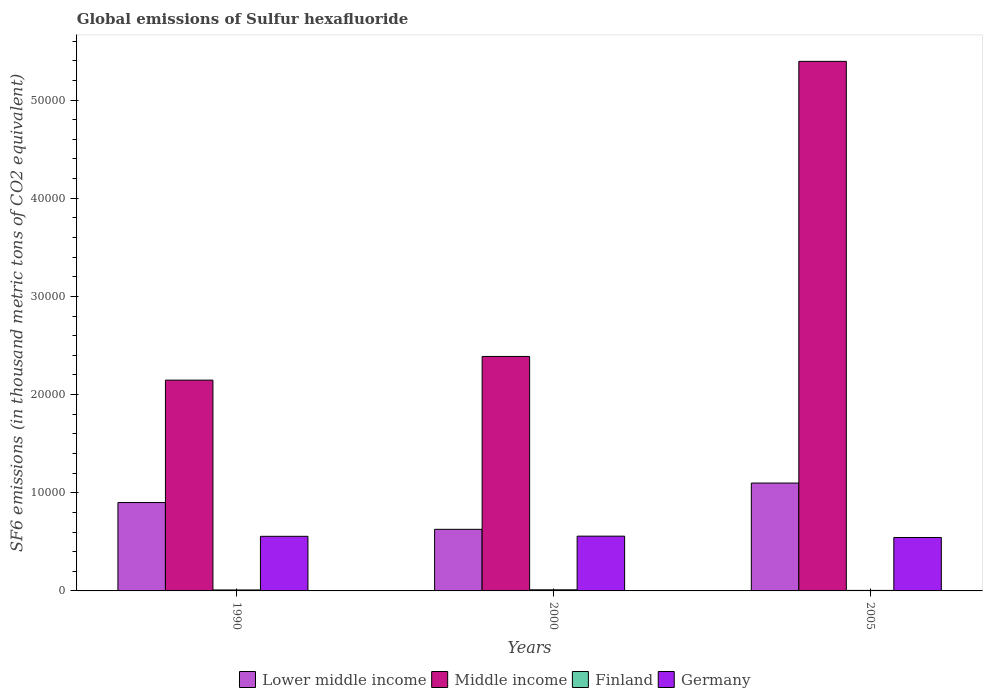How many groups of bars are there?
Your answer should be compact. 3. Are the number of bars per tick equal to the number of legend labels?
Your answer should be very brief. Yes. Are the number of bars on each tick of the X-axis equal?
Provide a succinct answer. Yes. How many bars are there on the 3rd tick from the left?
Give a very brief answer. 4. What is the label of the 3rd group of bars from the left?
Your answer should be compact. 2005. What is the global emissions of Sulfur hexafluoride in Middle income in 1990?
Offer a terse response. 2.15e+04. Across all years, what is the maximum global emissions of Sulfur hexafluoride in Finland?
Make the answer very short. 113.9. Across all years, what is the minimum global emissions of Sulfur hexafluoride in Germany?
Provide a succinct answer. 5443.2. In which year was the global emissions of Sulfur hexafluoride in Lower middle income maximum?
Your response must be concise. 2005. In which year was the global emissions of Sulfur hexafluoride in Germany minimum?
Make the answer very short. 2005. What is the total global emissions of Sulfur hexafluoride in Finland in the graph?
Keep it short and to the point. 263.2. What is the difference between the global emissions of Sulfur hexafluoride in Lower middle income in 1990 and that in 2000?
Keep it short and to the point. 2727.4. What is the difference between the global emissions of Sulfur hexafluoride in Germany in 2000 and the global emissions of Sulfur hexafluoride in Middle income in 1990?
Offer a terse response. -1.59e+04. What is the average global emissions of Sulfur hexafluoride in Germany per year?
Offer a very short reply. 5528.83. In the year 1990, what is the difference between the global emissions of Sulfur hexafluoride in Finland and global emissions of Sulfur hexafluoride in Lower middle income?
Provide a short and direct response. -8904.4. In how many years, is the global emissions of Sulfur hexafluoride in Germany greater than 2000 thousand metric tons?
Give a very brief answer. 3. What is the ratio of the global emissions of Sulfur hexafluoride in Germany in 2000 to that in 2005?
Your response must be concise. 1.03. Is the global emissions of Sulfur hexafluoride in Germany in 1990 less than that in 2005?
Provide a succinct answer. No. Is the difference between the global emissions of Sulfur hexafluoride in Finland in 2000 and 2005 greater than the difference between the global emissions of Sulfur hexafluoride in Lower middle income in 2000 and 2005?
Give a very brief answer. Yes. What is the difference between the highest and the second highest global emissions of Sulfur hexafluoride in Germany?
Give a very brief answer. 17.5. What is the difference between the highest and the lowest global emissions of Sulfur hexafluoride in Lower middle income?
Your response must be concise. 4713.67. What does the 3rd bar from the left in 2000 represents?
Your response must be concise. Finland. What does the 1st bar from the right in 1990 represents?
Offer a very short reply. Germany. Is it the case that in every year, the sum of the global emissions of Sulfur hexafluoride in Germany and global emissions of Sulfur hexafluoride in Middle income is greater than the global emissions of Sulfur hexafluoride in Finland?
Offer a terse response. Yes. Are all the bars in the graph horizontal?
Offer a terse response. No. How many years are there in the graph?
Keep it short and to the point. 3. What is the difference between two consecutive major ticks on the Y-axis?
Offer a very short reply. 10000. Does the graph contain grids?
Ensure brevity in your answer.  No. Where does the legend appear in the graph?
Keep it short and to the point. Bottom center. What is the title of the graph?
Provide a short and direct response. Global emissions of Sulfur hexafluoride. What is the label or title of the Y-axis?
Make the answer very short. SF6 emissions (in thousand metric tons of CO2 equivalent). What is the SF6 emissions (in thousand metric tons of CO2 equivalent) in Lower middle income in 1990?
Provide a succinct answer. 9002.8. What is the SF6 emissions (in thousand metric tons of CO2 equivalent) of Middle income in 1990?
Give a very brief answer. 2.15e+04. What is the SF6 emissions (in thousand metric tons of CO2 equivalent) in Finland in 1990?
Provide a succinct answer. 98.4. What is the SF6 emissions (in thousand metric tons of CO2 equivalent) in Germany in 1990?
Offer a very short reply. 5562.9. What is the SF6 emissions (in thousand metric tons of CO2 equivalent) in Lower middle income in 2000?
Provide a succinct answer. 6275.4. What is the SF6 emissions (in thousand metric tons of CO2 equivalent) in Middle income in 2000?
Ensure brevity in your answer.  2.39e+04. What is the SF6 emissions (in thousand metric tons of CO2 equivalent) in Finland in 2000?
Ensure brevity in your answer.  113.9. What is the SF6 emissions (in thousand metric tons of CO2 equivalent) of Germany in 2000?
Provide a short and direct response. 5580.4. What is the SF6 emissions (in thousand metric tons of CO2 equivalent) of Lower middle income in 2005?
Offer a terse response. 1.10e+04. What is the SF6 emissions (in thousand metric tons of CO2 equivalent) of Middle income in 2005?
Ensure brevity in your answer.  5.39e+04. What is the SF6 emissions (in thousand metric tons of CO2 equivalent) in Finland in 2005?
Provide a succinct answer. 50.9. What is the SF6 emissions (in thousand metric tons of CO2 equivalent) in Germany in 2005?
Give a very brief answer. 5443.2. Across all years, what is the maximum SF6 emissions (in thousand metric tons of CO2 equivalent) of Lower middle income?
Offer a very short reply. 1.10e+04. Across all years, what is the maximum SF6 emissions (in thousand metric tons of CO2 equivalent) of Middle income?
Offer a very short reply. 5.39e+04. Across all years, what is the maximum SF6 emissions (in thousand metric tons of CO2 equivalent) of Finland?
Ensure brevity in your answer.  113.9. Across all years, what is the maximum SF6 emissions (in thousand metric tons of CO2 equivalent) in Germany?
Make the answer very short. 5580.4. Across all years, what is the minimum SF6 emissions (in thousand metric tons of CO2 equivalent) of Lower middle income?
Your answer should be compact. 6275.4. Across all years, what is the minimum SF6 emissions (in thousand metric tons of CO2 equivalent) of Middle income?
Keep it short and to the point. 2.15e+04. Across all years, what is the minimum SF6 emissions (in thousand metric tons of CO2 equivalent) in Finland?
Offer a very short reply. 50.9. Across all years, what is the minimum SF6 emissions (in thousand metric tons of CO2 equivalent) in Germany?
Make the answer very short. 5443.2. What is the total SF6 emissions (in thousand metric tons of CO2 equivalent) in Lower middle income in the graph?
Offer a very short reply. 2.63e+04. What is the total SF6 emissions (in thousand metric tons of CO2 equivalent) in Middle income in the graph?
Offer a very short reply. 9.93e+04. What is the total SF6 emissions (in thousand metric tons of CO2 equivalent) in Finland in the graph?
Provide a short and direct response. 263.2. What is the total SF6 emissions (in thousand metric tons of CO2 equivalent) of Germany in the graph?
Provide a short and direct response. 1.66e+04. What is the difference between the SF6 emissions (in thousand metric tons of CO2 equivalent) in Lower middle income in 1990 and that in 2000?
Keep it short and to the point. 2727.4. What is the difference between the SF6 emissions (in thousand metric tons of CO2 equivalent) in Middle income in 1990 and that in 2000?
Give a very brief answer. -2413.4. What is the difference between the SF6 emissions (in thousand metric tons of CO2 equivalent) of Finland in 1990 and that in 2000?
Keep it short and to the point. -15.5. What is the difference between the SF6 emissions (in thousand metric tons of CO2 equivalent) in Germany in 1990 and that in 2000?
Keep it short and to the point. -17.5. What is the difference between the SF6 emissions (in thousand metric tons of CO2 equivalent) of Lower middle income in 1990 and that in 2005?
Provide a short and direct response. -1986.27. What is the difference between the SF6 emissions (in thousand metric tons of CO2 equivalent) in Middle income in 1990 and that in 2005?
Provide a short and direct response. -3.25e+04. What is the difference between the SF6 emissions (in thousand metric tons of CO2 equivalent) in Finland in 1990 and that in 2005?
Keep it short and to the point. 47.5. What is the difference between the SF6 emissions (in thousand metric tons of CO2 equivalent) in Germany in 1990 and that in 2005?
Keep it short and to the point. 119.7. What is the difference between the SF6 emissions (in thousand metric tons of CO2 equivalent) of Lower middle income in 2000 and that in 2005?
Make the answer very short. -4713.67. What is the difference between the SF6 emissions (in thousand metric tons of CO2 equivalent) in Middle income in 2000 and that in 2005?
Your answer should be compact. -3.01e+04. What is the difference between the SF6 emissions (in thousand metric tons of CO2 equivalent) of Finland in 2000 and that in 2005?
Your answer should be compact. 63. What is the difference between the SF6 emissions (in thousand metric tons of CO2 equivalent) of Germany in 2000 and that in 2005?
Keep it short and to the point. 137.2. What is the difference between the SF6 emissions (in thousand metric tons of CO2 equivalent) in Lower middle income in 1990 and the SF6 emissions (in thousand metric tons of CO2 equivalent) in Middle income in 2000?
Your answer should be compact. -1.49e+04. What is the difference between the SF6 emissions (in thousand metric tons of CO2 equivalent) of Lower middle income in 1990 and the SF6 emissions (in thousand metric tons of CO2 equivalent) of Finland in 2000?
Keep it short and to the point. 8888.9. What is the difference between the SF6 emissions (in thousand metric tons of CO2 equivalent) of Lower middle income in 1990 and the SF6 emissions (in thousand metric tons of CO2 equivalent) of Germany in 2000?
Your answer should be compact. 3422.4. What is the difference between the SF6 emissions (in thousand metric tons of CO2 equivalent) of Middle income in 1990 and the SF6 emissions (in thousand metric tons of CO2 equivalent) of Finland in 2000?
Make the answer very short. 2.14e+04. What is the difference between the SF6 emissions (in thousand metric tons of CO2 equivalent) in Middle income in 1990 and the SF6 emissions (in thousand metric tons of CO2 equivalent) in Germany in 2000?
Offer a very short reply. 1.59e+04. What is the difference between the SF6 emissions (in thousand metric tons of CO2 equivalent) of Finland in 1990 and the SF6 emissions (in thousand metric tons of CO2 equivalent) of Germany in 2000?
Make the answer very short. -5482. What is the difference between the SF6 emissions (in thousand metric tons of CO2 equivalent) of Lower middle income in 1990 and the SF6 emissions (in thousand metric tons of CO2 equivalent) of Middle income in 2005?
Provide a succinct answer. -4.49e+04. What is the difference between the SF6 emissions (in thousand metric tons of CO2 equivalent) in Lower middle income in 1990 and the SF6 emissions (in thousand metric tons of CO2 equivalent) in Finland in 2005?
Provide a succinct answer. 8951.9. What is the difference between the SF6 emissions (in thousand metric tons of CO2 equivalent) of Lower middle income in 1990 and the SF6 emissions (in thousand metric tons of CO2 equivalent) of Germany in 2005?
Ensure brevity in your answer.  3559.6. What is the difference between the SF6 emissions (in thousand metric tons of CO2 equivalent) of Middle income in 1990 and the SF6 emissions (in thousand metric tons of CO2 equivalent) of Finland in 2005?
Your answer should be very brief. 2.14e+04. What is the difference between the SF6 emissions (in thousand metric tons of CO2 equivalent) in Middle income in 1990 and the SF6 emissions (in thousand metric tons of CO2 equivalent) in Germany in 2005?
Your answer should be compact. 1.60e+04. What is the difference between the SF6 emissions (in thousand metric tons of CO2 equivalent) in Finland in 1990 and the SF6 emissions (in thousand metric tons of CO2 equivalent) in Germany in 2005?
Keep it short and to the point. -5344.8. What is the difference between the SF6 emissions (in thousand metric tons of CO2 equivalent) in Lower middle income in 2000 and the SF6 emissions (in thousand metric tons of CO2 equivalent) in Middle income in 2005?
Your answer should be compact. -4.77e+04. What is the difference between the SF6 emissions (in thousand metric tons of CO2 equivalent) of Lower middle income in 2000 and the SF6 emissions (in thousand metric tons of CO2 equivalent) of Finland in 2005?
Provide a short and direct response. 6224.5. What is the difference between the SF6 emissions (in thousand metric tons of CO2 equivalent) of Lower middle income in 2000 and the SF6 emissions (in thousand metric tons of CO2 equivalent) of Germany in 2005?
Provide a short and direct response. 832.2. What is the difference between the SF6 emissions (in thousand metric tons of CO2 equivalent) in Middle income in 2000 and the SF6 emissions (in thousand metric tons of CO2 equivalent) in Finland in 2005?
Your answer should be very brief. 2.38e+04. What is the difference between the SF6 emissions (in thousand metric tons of CO2 equivalent) of Middle income in 2000 and the SF6 emissions (in thousand metric tons of CO2 equivalent) of Germany in 2005?
Offer a terse response. 1.84e+04. What is the difference between the SF6 emissions (in thousand metric tons of CO2 equivalent) of Finland in 2000 and the SF6 emissions (in thousand metric tons of CO2 equivalent) of Germany in 2005?
Your answer should be compact. -5329.3. What is the average SF6 emissions (in thousand metric tons of CO2 equivalent) of Lower middle income per year?
Your response must be concise. 8755.76. What is the average SF6 emissions (in thousand metric tons of CO2 equivalent) in Middle income per year?
Your answer should be very brief. 3.31e+04. What is the average SF6 emissions (in thousand metric tons of CO2 equivalent) of Finland per year?
Give a very brief answer. 87.73. What is the average SF6 emissions (in thousand metric tons of CO2 equivalent) of Germany per year?
Ensure brevity in your answer.  5528.83. In the year 1990, what is the difference between the SF6 emissions (in thousand metric tons of CO2 equivalent) of Lower middle income and SF6 emissions (in thousand metric tons of CO2 equivalent) of Middle income?
Give a very brief answer. -1.25e+04. In the year 1990, what is the difference between the SF6 emissions (in thousand metric tons of CO2 equivalent) in Lower middle income and SF6 emissions (in thousand metric tons of CO2 equivalent) in Finland?
Make the answer very short. 8904.4. In the year 1990, what is the difference between the SF6 emissions (in thousand metric tons of CO2 equivalent) in Lower middle income and SF6 emissions (in thousand metric tons of CO2 equivalent) in Germany?
Your response must be concise. 3439.9. In the year 1990, what is the difference between the SF6 emissions (in thousand metric tons of CO2 equivalent) in Middle income and SF6 emissions (in thousand metric tons of CO2 equivalent) in Finland?
Provide a succinct answer. 2.14e+04. In the year 1990, what is the difference between the SF6 emissions (in thousand metric tons of CO2 equivalent) in Middle income and SF6 emissions (in thousand metric tons of CO2 equivalent) in Germany?
Ensure brevity in your answer.  1.59e+04. In the year 1990, what is the difference between the SF6 emissions (in thousand metric tons of CO2 equivalent) in Finland and SF6 emissions (in thousand metric tons of CO2 equivalent) in Germany?
Make the answer very short. -5464.5. In the year 2000, what is the difference between the SF6 emissions (in thousand metric tons of CO2 equivalent) in Lower middle income and SF6 emissions (in thousand metric tons of CO2 equivalent) in Middle income?
Your response must be concise. -1.76e+04. In the year 2000, what is the difference between the SF6 emissions (in thousand metric tons of CO2 equivalent) of Lower middle income and SF6 emissions (in thousand metric tons of CO2 equivalent) of Finland?
Make the answer very short. 6161.5. In the year 2000, what is the difference between the SF6 emissions (in thousand metric tons of CO2 equivalent) of Lower middle income and SF6 emissions (in thousand metric tons of CO2 equivalent) of Germany?
Offer a very short reply. 695. In the year 2000, what is the difference between the SF6 emissions (in thousand metric tons of CO2 equivalent) of Middle income and SF6 emissions (in thousand metric tons of CO2 equivalent) of Finland?
Your answer should be very brief. 2.38e+04. In the year 2000, what is the difference between the SF6 emissions (in thousand metric tons of CO2 equivalent) in Middle income and SF6 emissions (in thousand metric tons of CO2 equivalent) in Germany?
Offer a terse response. 1.83e+04. In the year 2000, what is the difference between the SF6 emissions (in thousand metric tons of CO2 equivalent) in Finland and SF6 emissions (in thousand metric tons of CO2 equivalent) in Germany?
Offer a very short reply. -5466.5. In the year 2005, what is the difference between the SF6 emissions (in thousand metric tons of CO2 equivalent) of Lower middle income and SF6 emissions (in thousand metric tons of CO2 equivalent) of Middle income?
Offer a terse response. -4.30e+04. In the year 2005, what is the difference between the SF6 emissions (in thousand metric tons of CO2 equivalent) in Lower middle income and SF6 emissions (in thousand metric tons of CO2 equivalent) in Finland?
Your answer should be compact. 1.09e+04. In the year 2005, what is the difference between the SF6 emissions (in thousand metric tons of CO2 equivalent) of Lower middle income and SF6 emissions (in thousand metric tons of CO2 equivalent) of Germany?
Make the answer very short. 5545.87. In the year 2005, what is the difference between the SF6 emissions (in thousand metric tons of CO2 equivalent) of Middle income and SF6 emissions (in thousand metric tons of CO2 equivalent) of Finland?
Offer a terse response. 5.39e+04. In the year 2005, what is the difference between the SF6 emissions (in thousand metric tons of CO2 equivalent) in Middle income and SF6 emissions (in thousand metric tons of CO2 equivalent) in Germany?
Offer a very short reply. 4.85e+04. In the year 2005, what is the difference between the SF6 emissions (in thousand metric tons of CO2 equivalent) in Finland and SF6 emissions (in thousand metric tons of CO2 equivalent) in Germany?
Offer a terse response. -5392.3. What is the ratio of the SF6 emissions (in thousand metric tons of CO2 equivalent) in Lower middle income in 1990 to that in 2000?
Offer a very short reply. 1.43. What is the ratio of the SF6 emissions (in thousand metric tons of CO2 equivalent) of Middle income in 1990 to that in 2000?
Your answer should be compact. 0.9. What is the ratio of the SF6 emissions (in thousand metric tons of CO2 equivalent) of Finland in 1990 to that in 2000?
Make the answer very short. 0.86. What is the ratio of the SF6 emissions (in thousand metric tons of CO2 equivalent) in Germany in 1990 to that in 2000?
Ensure brevity in your answer.  1. What is the ratio of the SF6 emissions (in thousand metric tons of CO2 equivalent) in Lower middle income in 1990 to that in 2005?
Ensure brevity in your answer.  0.82. What is the ratio of the SF6 emissions (in thousand metric tons of CO2 equivalent) of Middle income in 1990 to that in 2005?
Provide a short and direct response. 0.4. What is the ratio of the SF6 emissions (in thousand metric tons of CO2 equivalent) in Finland in 1990 to that in 2005?
Your response must be concise. 1.93. What is the ratio of the SF6 emissions (in thousand metric tons of CO2 equivalent) in Germany in 1990 to that in 2005?
Offer a terse response. 1.02. What is the ratio of the SF6 emissions (in thousand metric tons of CO2 equivalent) of Lower middle income in 2000 to that in 2005?
Keep it short and to the point. 0.57. What is the ratio of the SF6 emissions (in thousand metric tons of CO2 equivalent) in Middle income in 2000 to that in 2005?
Give a very brief answer. 0.44. What is the ratio of the SF6 emissions (in thousand metric tons of CO2 equivalent) of Finland in 2000 to that in 2005?
Give a very brief answer. 2.24. What is the ratio of the SF6 emissions (in thousand metric tons of CO2 equivalent) in Germany in 2000 to that in 2005?
Your response must be concise. 1.03. What is the difference between the highest and the second highest SF6 emissions (in thousand metric tons of CO2 equivalent) in Lower middle income?
Provide a succinct answer. 1986.27. What is the difference between the highest and the second highest SF6 emissions (in thousand metric tons of CO2 equivalent) of Middle income?
Your response must be concise. 3.01e+04. What is the difference between the highest and the lowest SF6 emissions (in thousand metric tons of CO2 equivalent) of Lower middle income?
Give a very brief answer. 4713.67. What is the difference between the highest and the lowest SF6 emissions (in thousand metric tons of CO2 equivalent) of Middle income?
Provide a succinct answer. 3.25e+04. What is the difference between the highest and the lowest SF6 emissions (in thousand metric tons of CO2 equivalent) in Germany?
Make the answer very short. 137.2. 